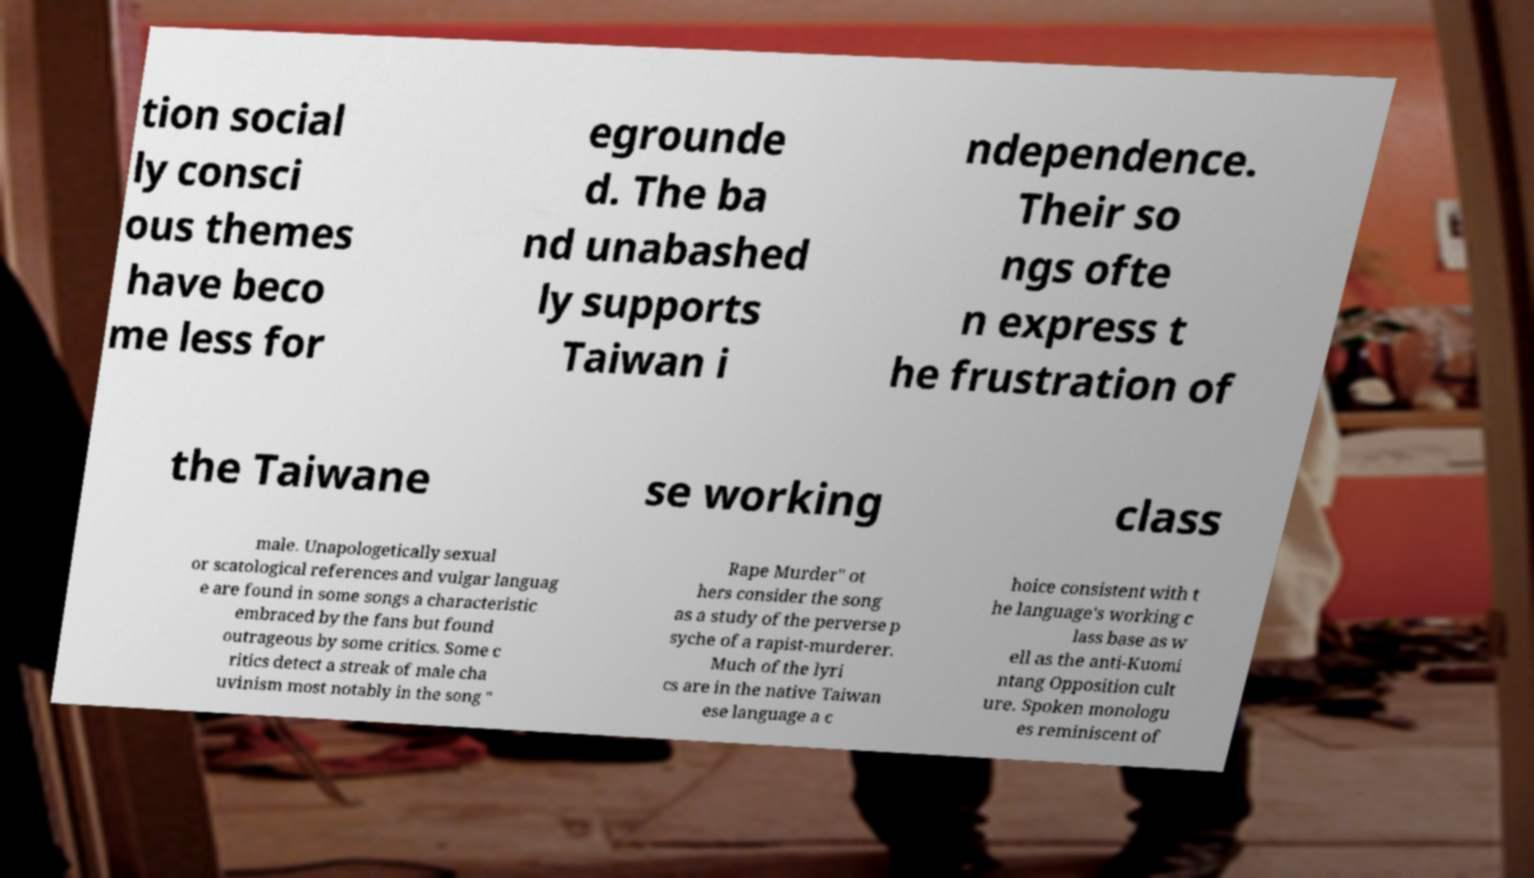Could you assist in decoding the text presented in this image and type it out clearly? tion social ly consci ous themes have beco me less for egrounde d. The ba nd unabashed ly supports Taiwan i ndependence. Their so ngs ofte n express t he frustration of the Taiwane se working class male. Unapologetically sexual or scatological references and vulgar languag e are found in some songs a characteristic embraced by the fans but found outrageous by some critics. Some c ritics detect a streak of male cha uvinism most notably in the song " Rape Murder" ot hers consider the song as a study of the perverse p syche of a rapist-murderer. Much of the lyri cs are in the native Taiwan ese language a c hoice consistent with t he language's working c lass base as w ell as the anti-Kuomi ntang Opposition cult ure. Spoken monologu es reminiscent of 